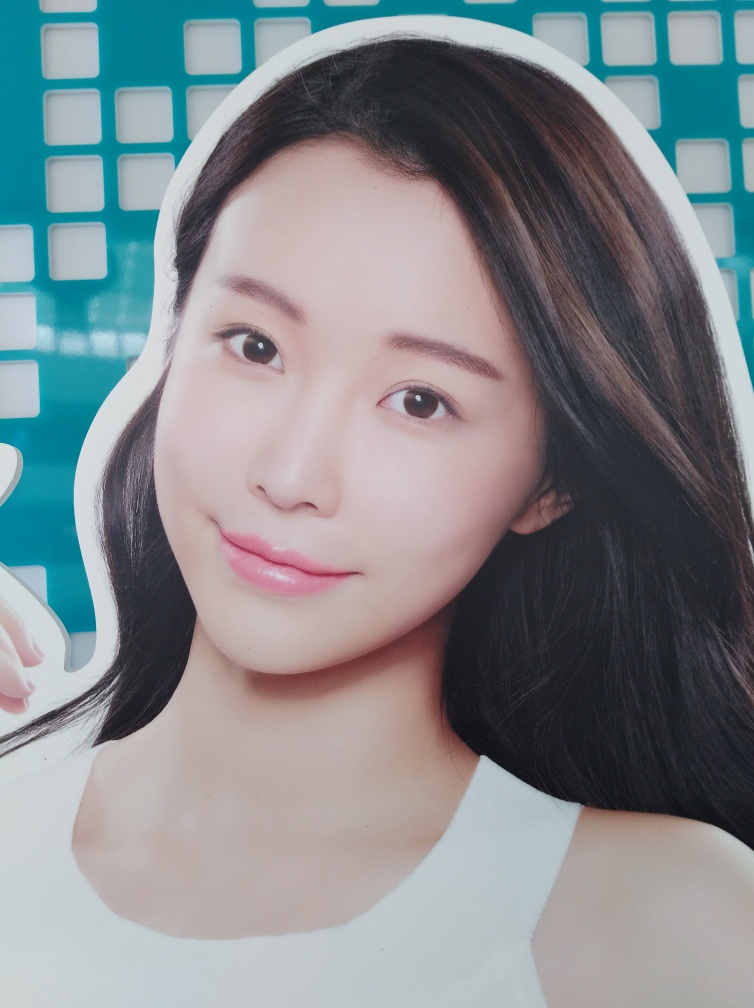What kind of product or object is being advertised here? Based on the image, it appears to be an advertisement for a beauty product or service, with a focus on clear and radiant facial complexion. 